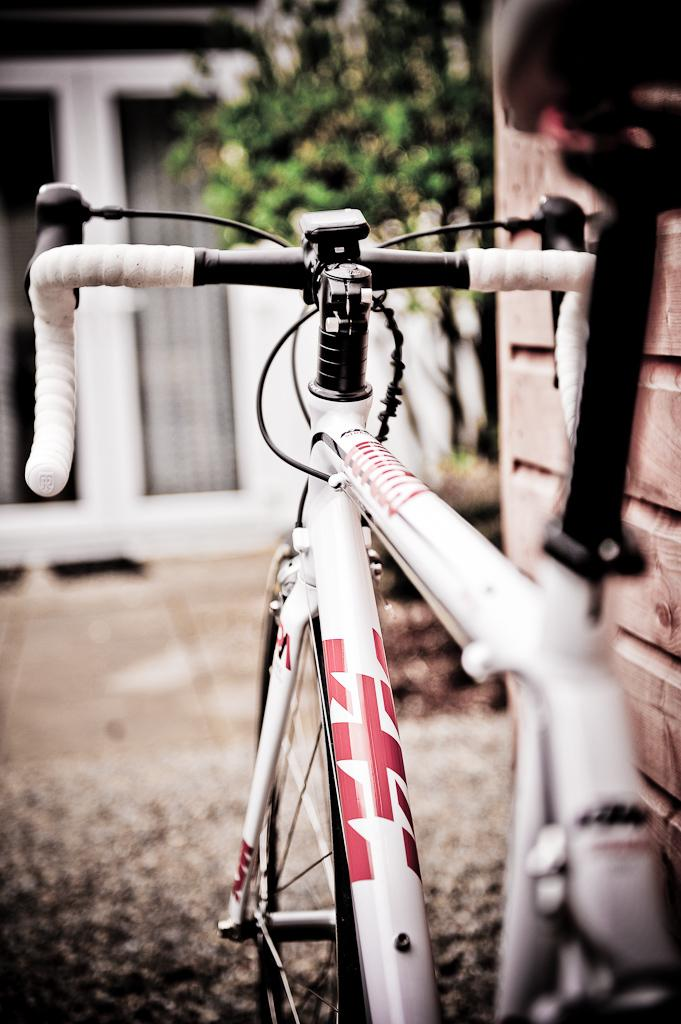What is the main object in the image? There is a cycle in the image. What color is the cycle? The cycle is white in color. What can be seen in the background of the image? There is a tree at the top of the image. What type of chain is being used for reading in the image? There is no chain or reading activity present in the image; it features a white cycle and a tree in the background. 